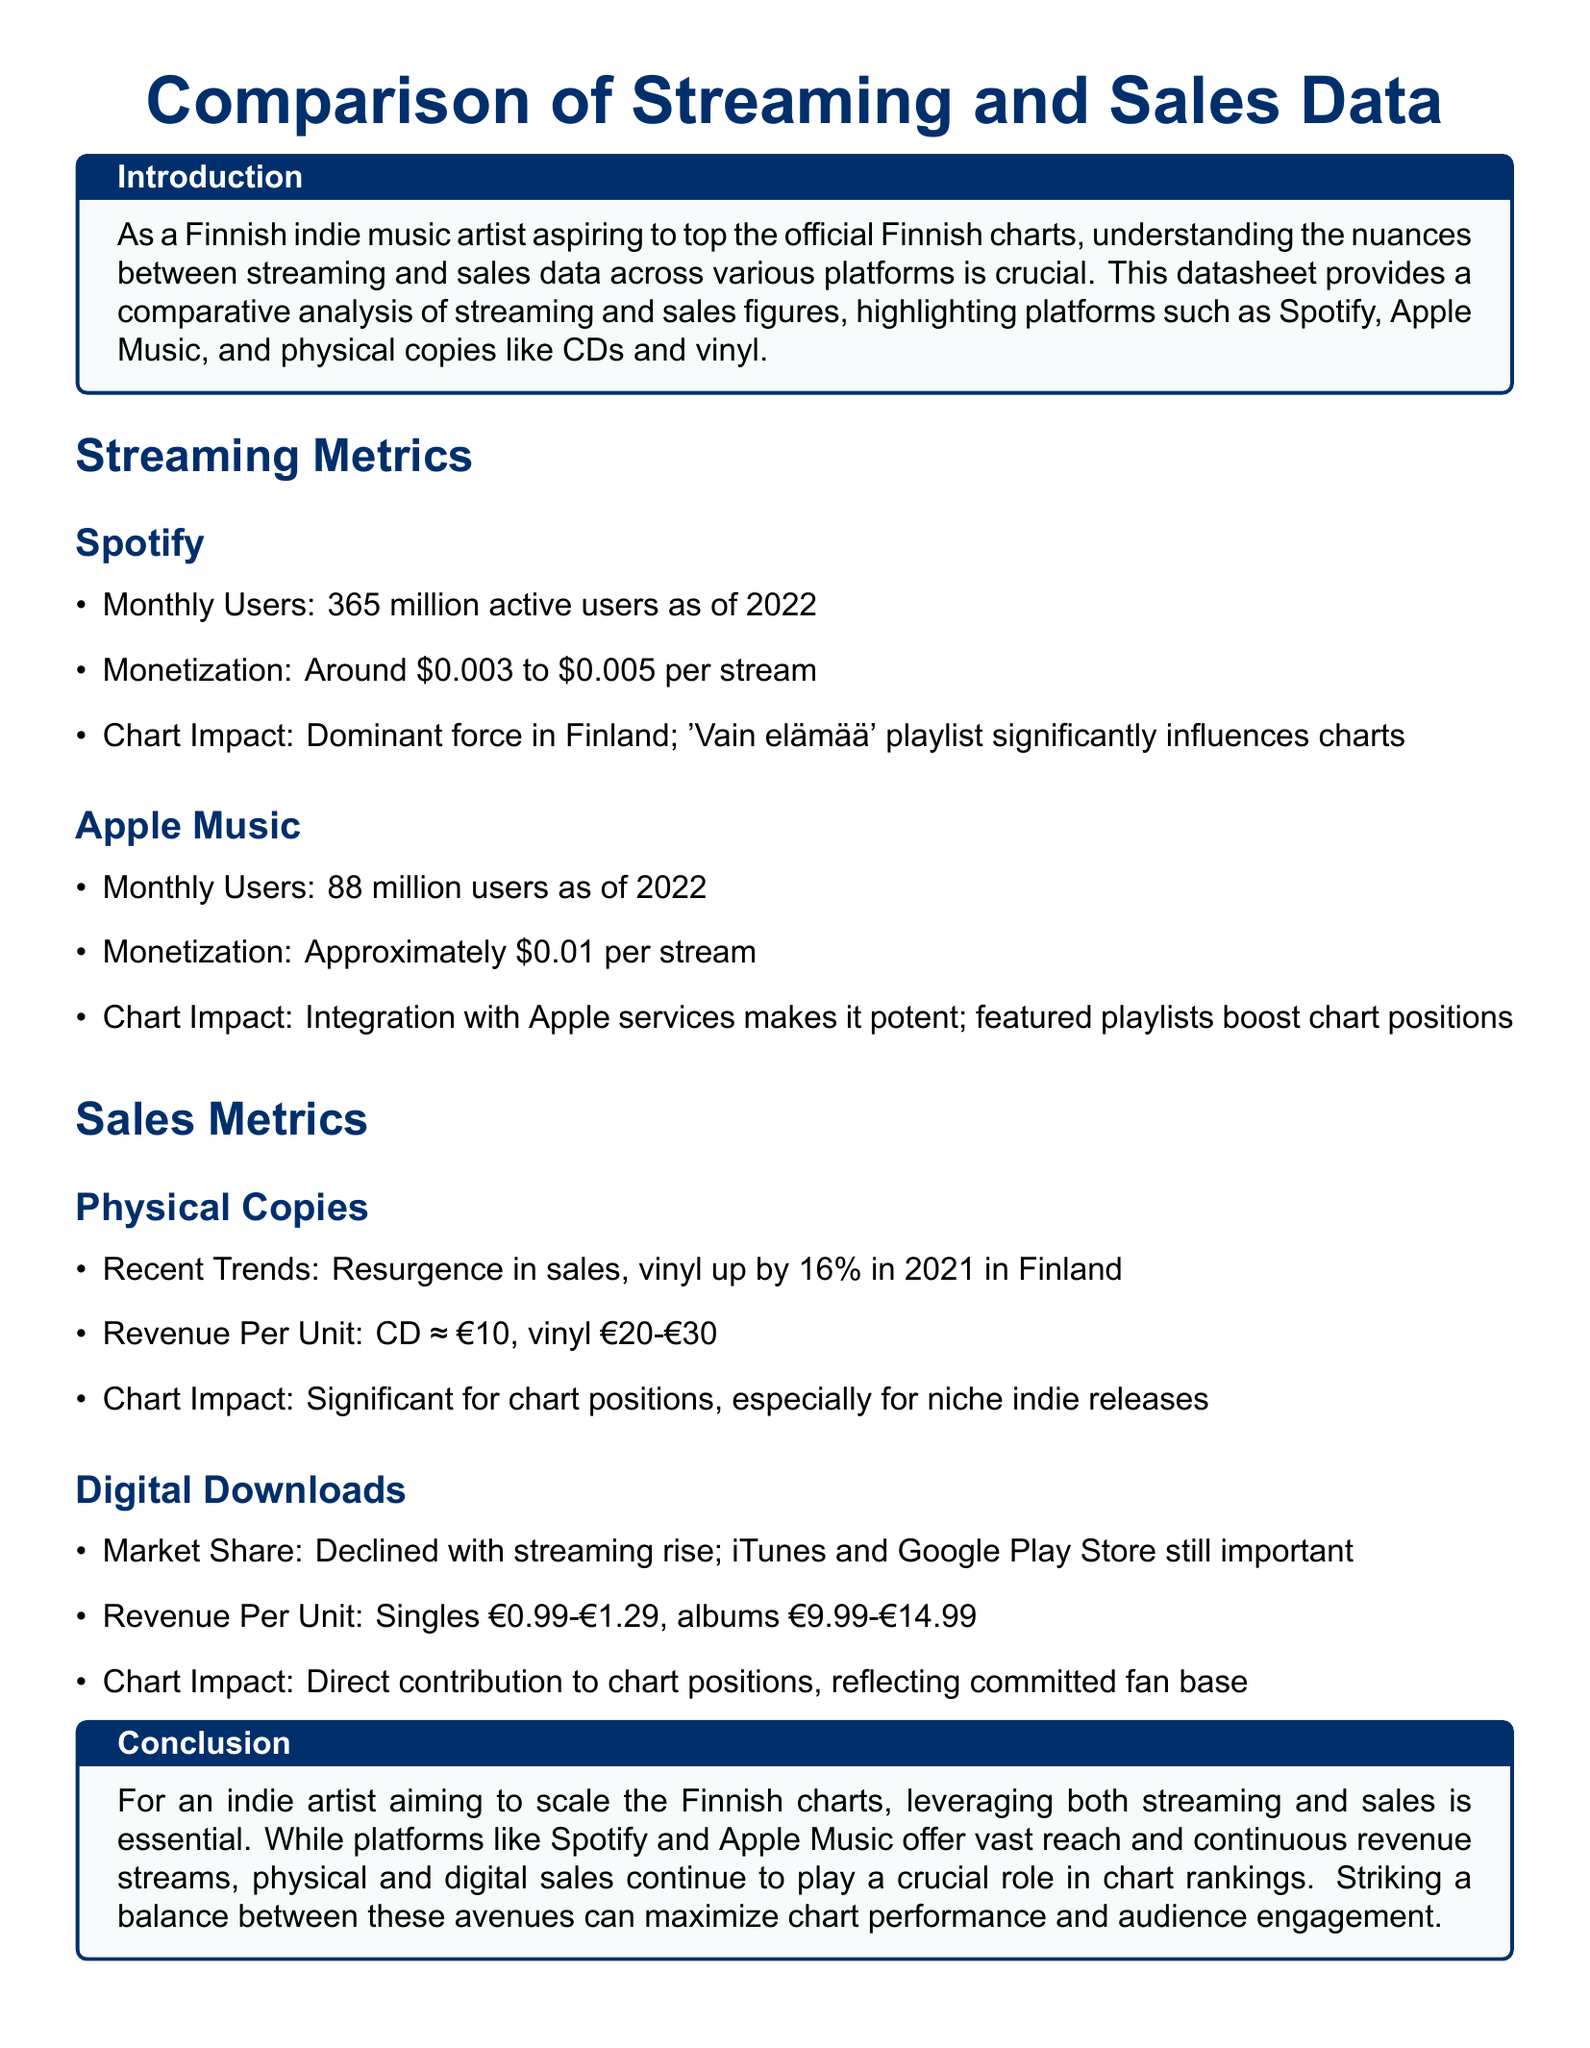What is the number of monthly users on Spotify? The document states that Spotify has 365 million active users as of 2022.
Answer: 365 million What is the monetization per stream on Apple Music? According to the document, Apple Music pays approximately $0.01 per stream.
Answer: $0.01 What percentage did vinyl sales increase by in 2021 in Finland? The document mentions that vinyl sales increased by 16% in 2021.
Answer: 16% What is the revenue per unit for a CD? The document indicates that the revenue per unit for a CD is approximately €10.
Answer: €10 What impact does the 'Vain elämää' playlist have? The document notes that the 'Vain elämää' playlist is a dominant force influencing charts in Finland.
Answer: Significant influence How does streaming affect market share for digital downloads? The document explains that digital download market share has declined with the rise of streaming.
Answer: Declined What is the revenue range for a digital album? According to the document, the revenue for digital albums ranges from €9.99 to €14.99.
Answer: €9.99-€14.99 Which platforms significantly impact chart positions? The document highlights that both streaming and sales, including physical copies, significantly affect chart positions.
Answer: Streaming and sales What is the recent trend in physical sales? The document states that there is a resurgence in physical sales, particularly in vinyl.
Answer: Resurgence 